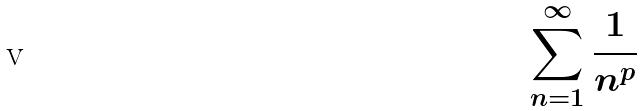Convert formula to latex. <formula><loc_0><loc_0><loc_500><loc_500>\sum _ { n = 1 } ^ { \infty } \frac { 1 } { n ^ { p } }</formula> 